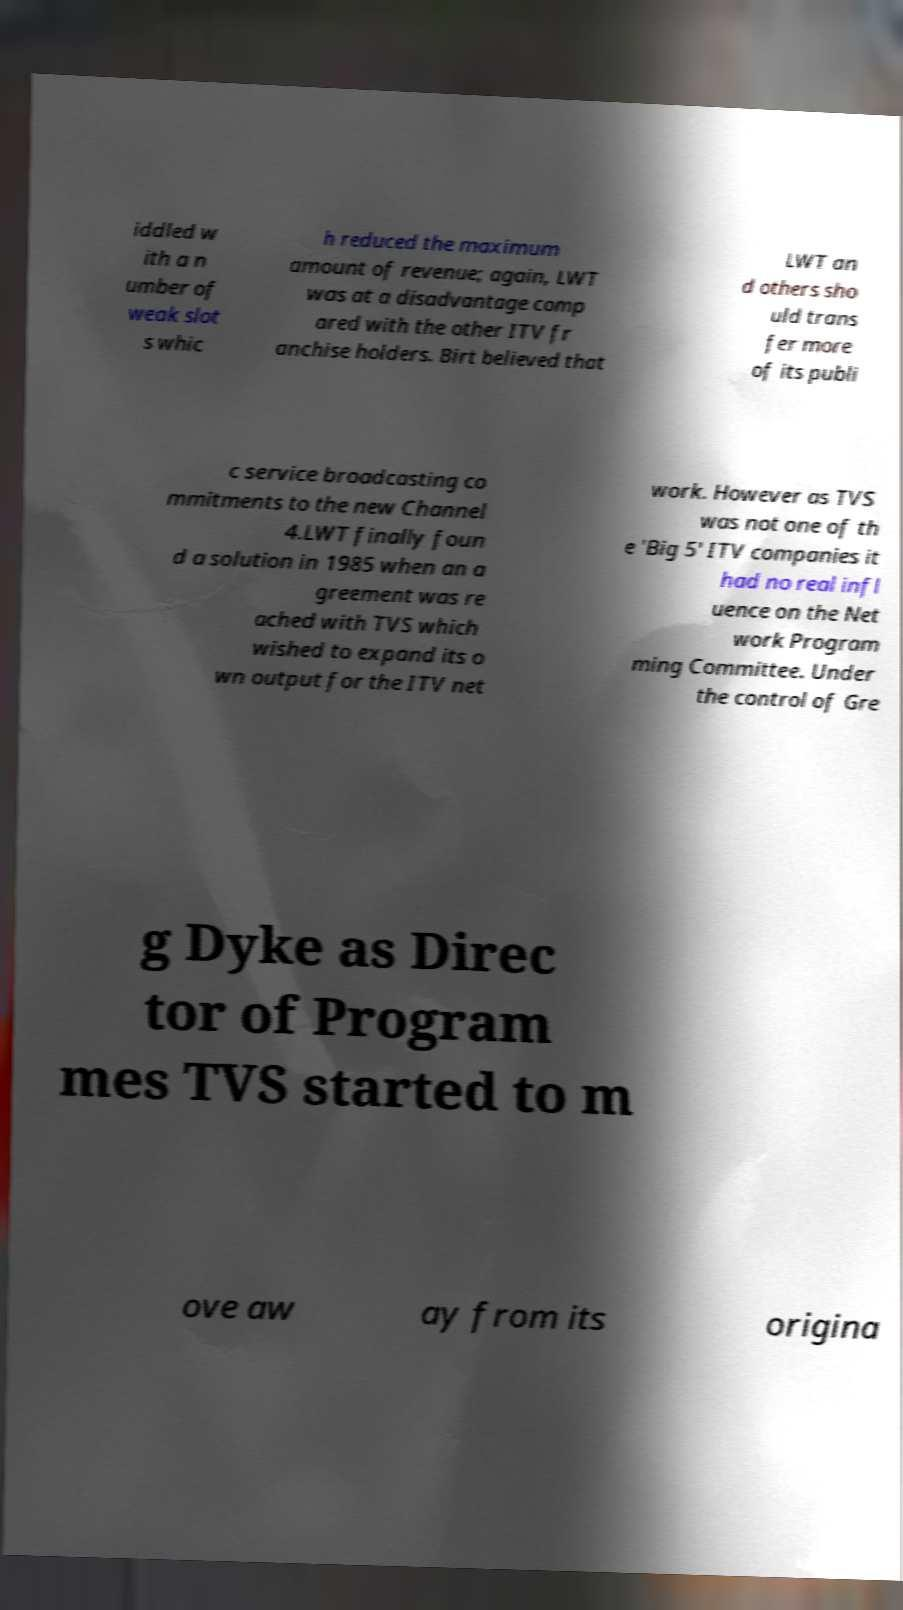Could you assist in decoding the text presented in this image and type it out clearly? iddled w ith a n umber of weak slot s whic h reduced the maximum amount of revenue; again, LWT was at a disadvantage comp ared with the other ITV fr anchise holders. Birt believed that LWT an d others sho uld trans fer more of its publi c service broadcasting co mmitments to the new Channel 4.LWT finally foun d a solution in 1985 when an a greement was re ached with TVS which wished to expand its o wn output for the ITV net work. However as TVS was not one of th e 'Big 5' ITV companies it had no real infl uence on the Net work Program ming Committee. Under the control of Gre g Dyke as Direc tor of Program mes TVS started to m ove aw ay from its origina 